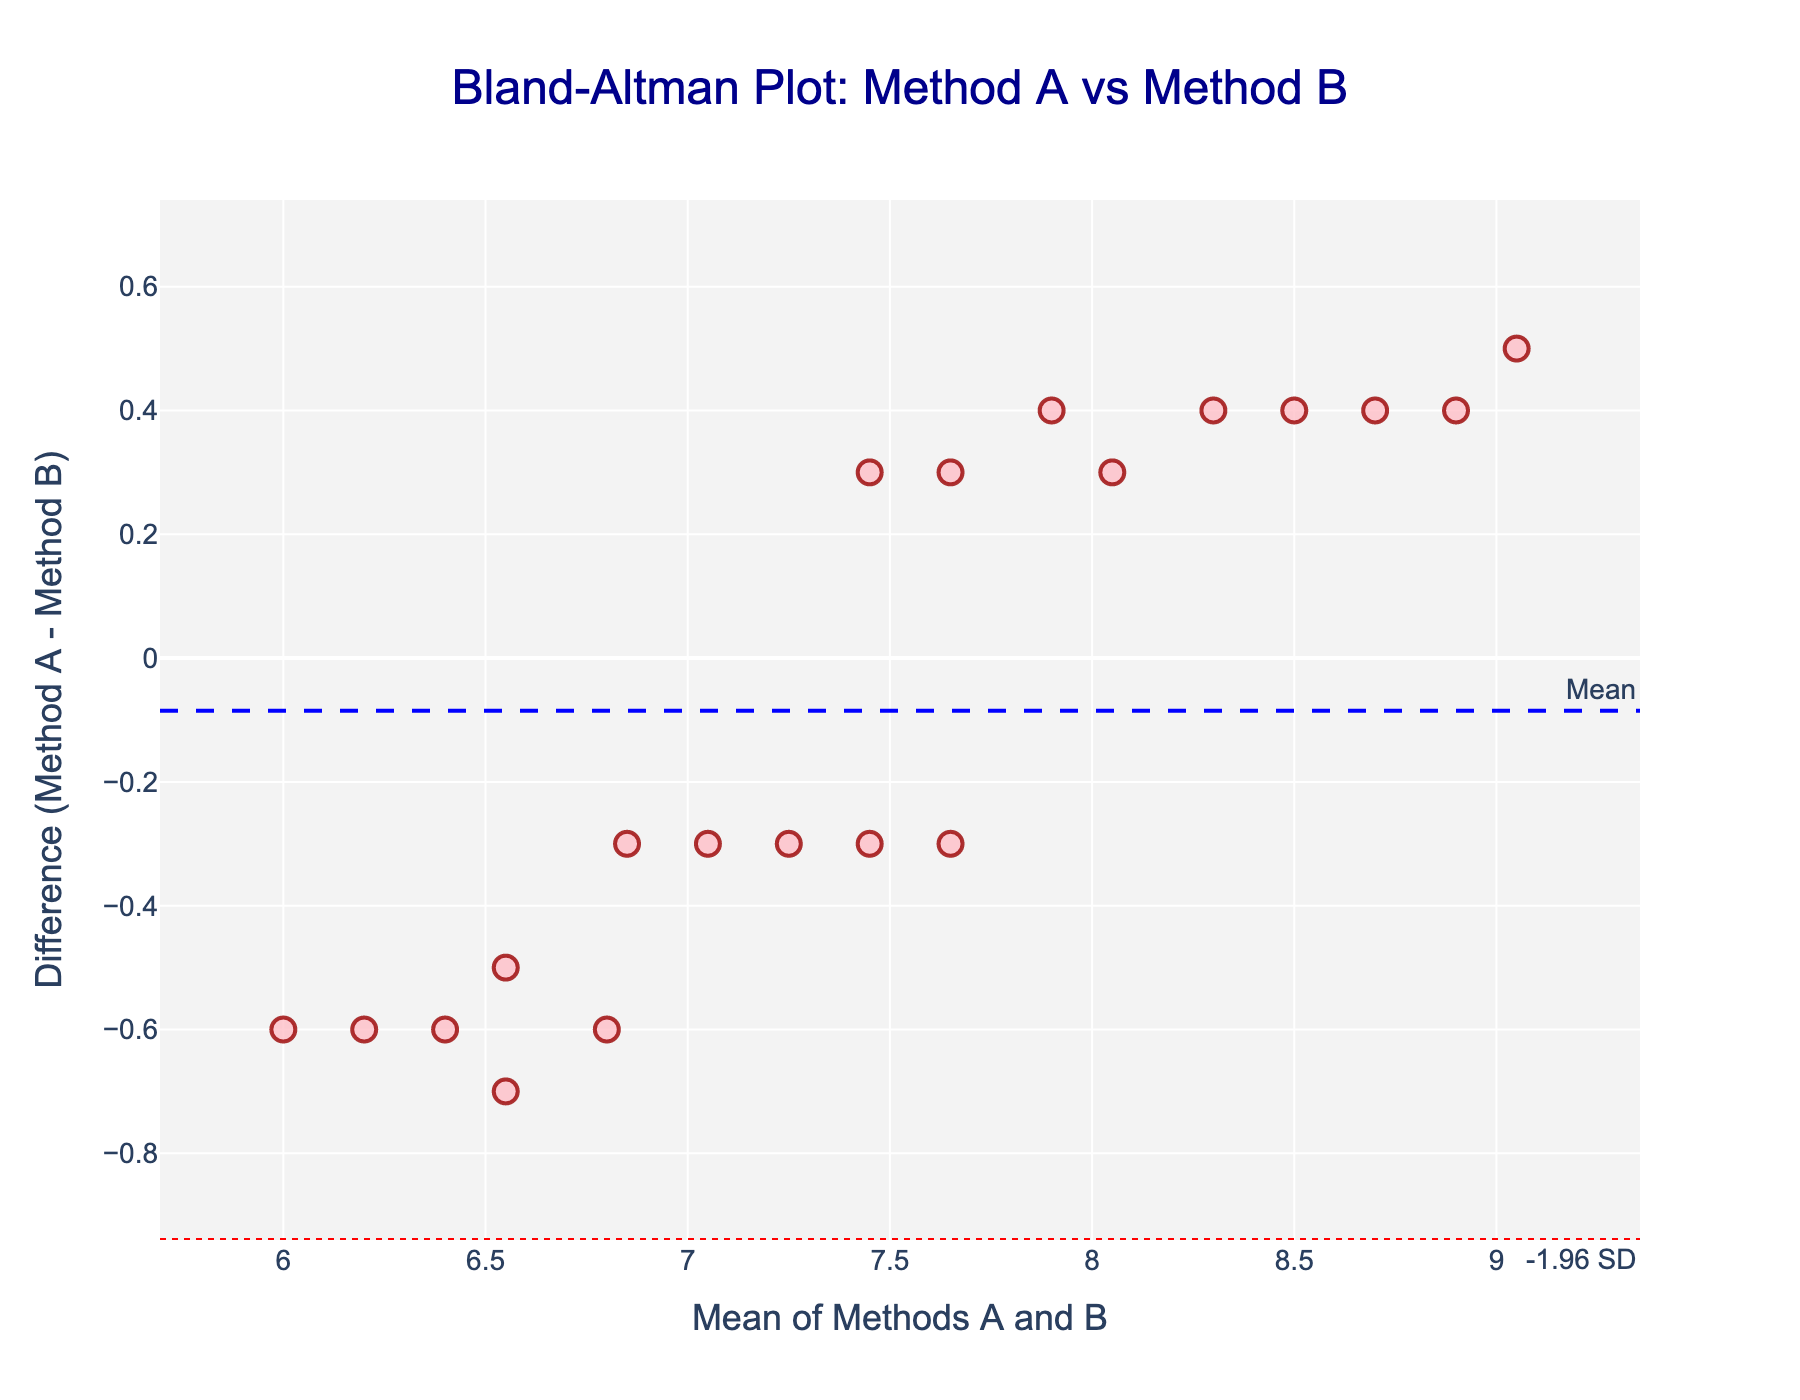How many data points are shown in the Bland-Altman plot? To determine the number of data points, count the individual markers displayed in the scatter plot.
Answer: 20 What is the title of the Bland-Altman plot? The title is typically displayed at the top of the plot and provides a summary of what the figure represents.
Answer: Bland-Altman Plot: Method A vs Method B What do the red dotted lines in the plot represent? The red dotted lines represent the upper and lower limits of agreement, calculated as the mean difference ± 1.96 times the standard deviation of the differences.
Answer: Limits of agreement What does the blue dashed line in the plot represent? The blue dashed line indicates the mean difference between the two methods of measurement. This is the average of all the differences between Method A and Method B.
Answer: Mean difference What is the mean difference displayed in the plot? The mean difference can be identified by the value marked along the blue dashed line which is annotated with "Mean."
Answer: 0.22 How many outliers are there beyond the limits of agreement in the plot? To identify outliers, count the number of data points that fall outside the upper and lower red dotted lines.
Answer: 0 Are most data points above or below the mean difference line? Observe the scatterplot to see if there are more data points positioned above or below the blue dashed line (mean difference).
Answer: Above What can be inferred if most differences cluster around the mean difference line? When differences cluster around the mean line, it implies that the two methods are generally in agreement. This indicates that the measurements are consistent with each other around the mean.
Answer: Consistent agreement What does a mean difference of 0.22 indicate about Method A and Method B? A mean difference of 0.22 suggests that, on average, Method A's measurements are slightly higher than those of Method B by 0.22 units.
Answer: Method A is slightly higher What might it imply if you see a pattern (e.g., funnel shape) in the Bland-Altman plot? Patterns such as a funnel shape could suggest heteroscedasticity, indicating that the variability between methods changes with the magnitude of the measurement, thus questioning the consistency of measurements across the range of data.
Answer: Heteroscedasticity 